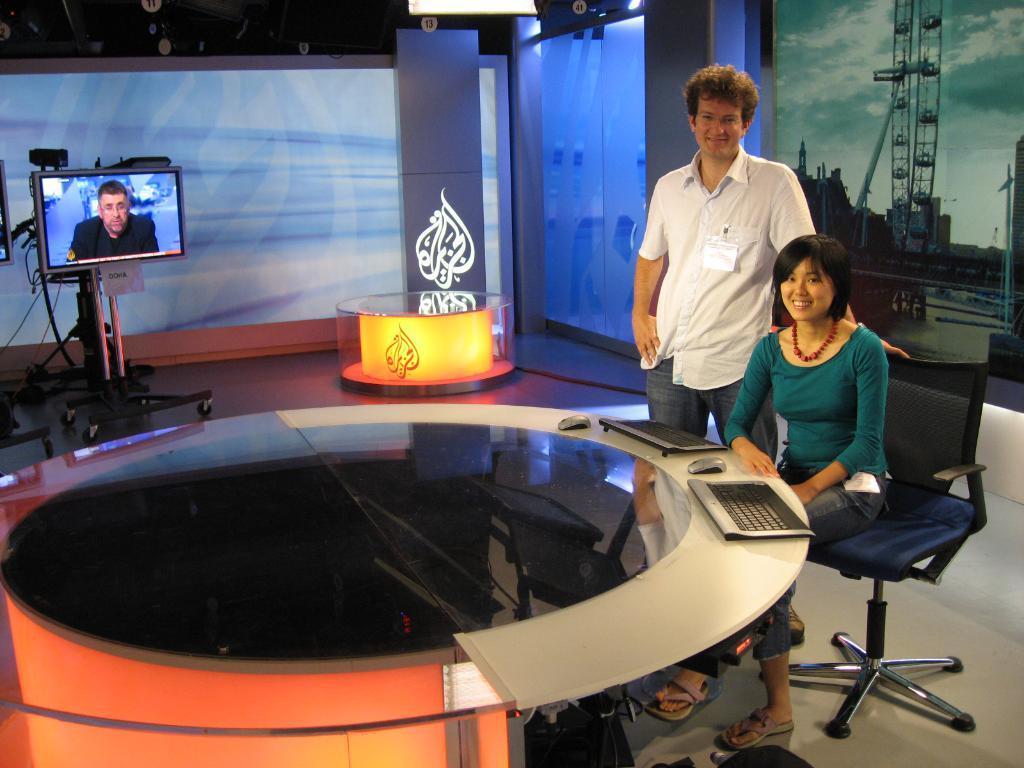Please provide a concise description of this image. Here we can see a woman sitting on a chair and beside her we can see a man standing both are in front of a table there are keyboards and mouses present on it and on the left side we can see a monitor present with somebody in it 